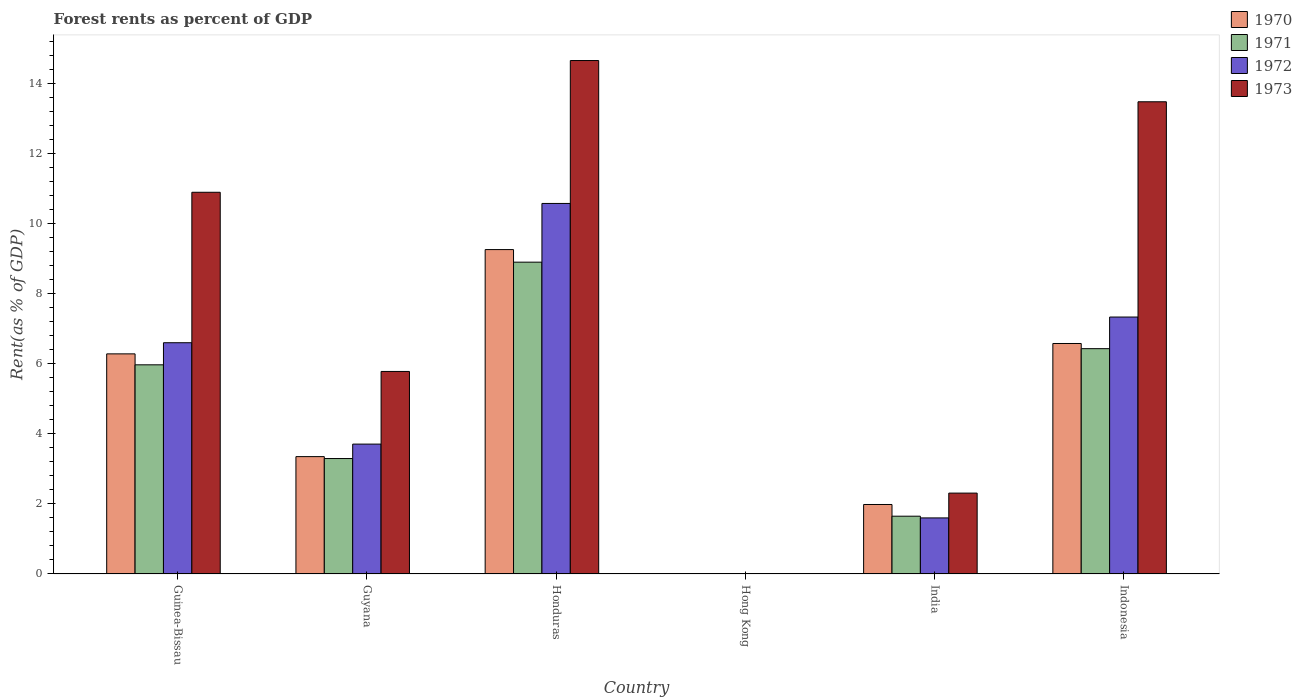How many different coloured bars are there?
Keep it short and to the point. 4. Are the number of bars per tick equal to the number of legend labels?
Provide a short and direct response. Yes. Are the number of bars on each tick of the X-axis equal?
Provide a succinct answer. Yes. How many bars are there on the 2nd tick from the left?
Keep it short and to the point. 4. How many bars are there on the 4th tick from the right?
Offer a terse response. 4. What is the label of the 2nd group of bars from the left?
Your response must be concise. Guyana. In how many cases, is the number of bars for a given country not equal to the number of legend labels?
Your answer should be compact. 0. What is the forest rent in 1970 in Guyana?
Provide a short and direct response. 3.35. Across all countries, what is the maximum forest rent in 1971?
Offer a terse response. 8.89. Across all countries, what is the minimum forest rent in 1973?
Provide a succinct answer. 0.01. In which country was the forest rent in 1970 maximum?
Ensure brevity in your answer.  Honduras. In which country was the forest rent in 1970 minimum?
Your answer should be compact. Hong Kong. What is the total forest rent in 1972 in the graph?
Ensure brevity in your answer.  29.8. What is the difference between the forest rent in 1971 in Guinea-Bissau and that in Honduras?
Give a very brief answer. -2.93. What is the difference between the forest rent in 1972 in Hong Kong and the forest rent in 1970 in Indonesia?
Offer a very short reply. -6.57. What is the average forest rent in 1971 per country?
Give a very brief answer. 4.37. What is the difference between the forest rent of/in 1972 and forest rent of/in 1973 in India?
Provide a succinct answer. -0.71. What is the ratio of the forest rent in 1972 in Guinea-Bissau to that in Guyana?
Keep it short and to the point. 1.78. What is the difference between the highest and the second highest forest rent in 1970?
Give a very brief answer. 2.68. What is the difference between the highest and the lowest forest rent in 1970?
Make the answer very short. 9.24. In how many countries, is the forest rent in 1972 greater than the average forest rent in 1972 taken over all countries?
Keep it short and to the point. 3. Is it the case that in every country, the sum of the forest rent in 1972 and forest rent in 1973 is greater than the sum of forest rent in 1970 and forest rent in 1971?
Offer a terse response. No. What does the 2nd bar from the right in Indonesia represents?
Provide a short and direct response. 1972. How many bars are there?
Your answer should be very brief. 24. Are all the bars in the graph horizontal?
Make the answer very short. No. How many countries are there in the graph?
Offer a terse response. 6. What is the difference between two consecutive major ticks on the Y-axis?
Provide a short and direct response. 2. Are the values on the major ticks of Y-axis written in scientific E-notation?
Provide a short and direct response. No. Does the graph contain any zero values?
Offer a very short reply. No. How are the legend labels stacked?
Provide a short and direct response. Vertical. What is the title of the graph?
Provide a short and direct response. Forest rents as percent of GDP. What is the label or title of the Y-axis?
Make the answer very short. Rent(as % of GDP). What is the Rent(as % of GDP) in 1970 in Guinea-Bissau?
Ensure brevity in your answer.  6.28. What is the Rent(as % of GDP) of 1971 in Guinea-Bissau?
Offer a terse response. 5.97. What is the Rent(as % of GDP) in 1972 in Guinea-Bissau?
Make the answer very short. 6.6. What is the Rent(as % of GDP) of 1973 in Guinea-Bissau?
Make the answer very short. 10.89. What is the Rent(as % of GDP) of 1970 in Guyana?
Give a very brief answer. 3.35. What is the Rent(as % of GDP) in 1971 in Guyana?
Ensure brevity in your answer.  3.29. What is the Rent(as % of GDP) in 1972 in Guyana?
Your response must be concise. 3.7. What is the Rent(as % of GDP) of 1973 in Guyana?
Keep it short and to the point. 5.78. What is the Rent(as % of GDP) of 1970 in Honduras?
Give a very brief answer. 9.25. What is the Rent(as % of GDP) of 1971 in Honduras?
Offer a very short reply. 8.89. What is the Rent(as % of GDP) in 1972 in Honduras?
Make the answer very short. 10.57. What is the Rent(as % of GDP) of 1973 in Honduras?
Provide a succinct answer. 14.64. What is the Rent(as % of GDP) in 1970 in Hong Kong?
Ensure brevity in your answer.  0.01. What is the Rent(as % of GDP) of 1971 in Hong Kong?
Provide a short and direct response. 0.01. What is the Rent(as % of GDP) of 1972 in Hong Kong?
Provide a succinct answer. 0.01. What is the Rent(as % of GDP) of 1973 in Hong Kong?
Offer a very short reply. 0.01. What is the Rent(as % of GDP) in 1970 in India?
Give a very brief answer. 1.98. What is the Rent(as % of GDP) in 1971 in India?
Ensure brevity in your answer.  1.65. What is the Rent(as % of GDP) in 1972 in India?
Offer a very short reply. 1.6. What is the Rent(as % of GDP) in 1973 in India?
Give a very brief answer. 2.31. What is the Rent(as % of GDP) of 1970 in Indonesia?
Your response must be concise. 6.57. What is the Rent(as % of GDP) in 1971 in Indonesia?
Your answer should be very brief. 6.43. What is the Rent(as % of GDP) in 1972 in Indonesia?
Offer a very short reply. 7.33. What is the Rent(as % of GDP) in 1973 in Indonesia?
Your answer should be very brief. 13.47. Across all countries, what is the maximum Rent(as % of GDP) in 1970?
Provide a succinct answer. 9.25. Across all countries, what is the maximum Rent(as % of GDP) in 1971?
Make the answer very short. 8.89. Across all countries, what is the maximum Rent(as % of GDP) in 1972?
Ensure brevity in your answer.  10.57. Across all countries, what is the maximum Rent(as % of GDP) of 1973?
Offer a very short reply. 14.64. Across all countries, what is the minimum Rent(as % of GDP) of 1970?
Offer a terse response. 0.01. Across all countries, what is the minimum Rent(as % of GDP) of 1971?
Your answer should be very brief. 0.01. Across all countries, what is the minimum Rent(as % of GDP) of 1972?
Provide a short and direct response. 0.01. Across all countries, what is the minimum Rent(as % of GDP) of 1973?
Your answer should be compact. 0.01. What is the total Rent(as % of GDP) in 1970 in the graph?
Your response must be concise. 27.44. What is the total Rent(as % of GDP) in 1971 in the graph?
Offer a terse response. 26.23. What is the total Rent(as % of GDP) in 1972 in the graph?
Your response must be concise. 29.8. What is the total Rent(as % of GDP) of 1973 in the graph?
Offer a terse response. 47.09. What is the difference between the Rent(as % of GDP) of 1970 in Guinea-Bissau and that in Guyana?
Offer a terse response. 2.93. What is the difference between the Rent(as % of GDP) in 1971 in Guinea-Bissau and that in Guyana?
Your response must be concise. 2.67. What is the difference between the Rent(as % of GDP) in 1972 in Guinea-Bissau and that in Guyana?
Provide a succinct answer. 2.89. What is the difference between the Rent(as % of GDP) in 1973 in Guinea-Bissau and that in Guyana?
Offer a terse response. 5.11. What is the difference between the Rent(as % of GDP) of 1970 in Guinea-Bissau and that in Honduras?
Offer a very short reply. -2.97. What is the difference between the Rent(as % of GDP) in 1971 in Guinea-Bissau and that in Honduras?
Make the answer very short. -2.93. What is the difference between the Rent(as % of GDP) in 1972 in Guinea-Bissau and that in Honduras?
Ensure brevity in your answer.  -3.97. What is the difference between the Rent(as % of GDP) in 1973 in Guinea-Bissau and that in Honduras?
Provide a succinct answer. -3.76. What is the difference between the Rent(as % of GDP) in 1970 in Guinea-Bissau and that in Hong Kong?
Ensure brevity in your answer.  6.27. What is the difference between the Rent(as % of GDP) of 1971 in Guinea-Bissau and that in Hong Kong?
Your response must be concise. 5.96. What is the difference between the Rent(as % of GDP) in 1972 in Guinea-Bissau and that in Hong Kong?
Your answer should be compact. 6.59. What is the difference between the Rent(as % of GDP) of 1973 in Guinea-Bissau and that in Hong Kong?
Provide a short and direct response. 10.88. What is the difference between the Rent(as % of GDP) of 1970 in Guinea-Bissau and that in India?
Offer a very short reply. 4.3. What is the difference between the Rent(as % of GDP) of 1971 in Guinea-Bissau and that in India?
Offer a terse response. 4.32. What is the difference between the Rent(as % of GDP) of 1972 in Guinea-Bissau and that in India?
Your answer should be very brief. 5. What is the difference between the Rent(as % of GDP) in 1973 in Guinea-Bissau and that in India?
Provide a short and direct response. 8.58. What is the difference between the Rent(as % of GDP) of 1970 in Guinea-Bissau and that in Indonesia?
Keep it short and to the point. -0.3. What is the difference between the Rent(as % of GDP) of 1971 in Guinea-Bissau and that in Indonesia?
Provide a succinct answer. -0.46. What is the difference between the Rent(as % of GDP) in 1972 in Guinea-Bissau and that in Indonesia?
Provide a succinct answer. -0.73. What is the difference between the Rent(as % of GDP) in 1973 in Guinea-Bissau and that in Indonesia?
Your answer should be compact. -2.58. What is the difference between the Rent(as % of GDP) in 1970 in Guyana and that in Honduras?
Give a very brief answer. -5.9. What is the difference between the Rent(as % of GDP) in 1971 in Guyana and that in Honduras?
Your answer should be compact. -5.6. What is the difference between the Rent(as % of GDP) in 1972 in Guyana and that in Honduras?
Provide a short and direct response. -6.86. What is the difference between the Rent(as % of GDP) in 1973 in Guyana and that in Honduras?
Provide a succinct answer. -8.87. What is the difference between the Rent(as % of GDP) of 1970 in Guyana and that in Hong Kong?
Provide a succinct answer. 3.34. What is the difference between the Rent(as % of GDP) in 1971 in Guyana and that in Hong Kong?
Ensure brevity in your answer.  3.29. What is the difference between the Rent(as % of GDP) in 1972 in Guyana and that in Hong Kong?
Ensure brevity in your answer.  3.7. What is the difference between the Rent(as % of GDP) of 1973 in Guyana and that in Hong Kong?
Provide a succinct answer. 5.77. What is the difference between the Rent(as % of GDP) of 1970 in Guyana and that in India?
Your answer should be very brief. 1.37. What is the difference between the Rent(as % of GDP) of 1971 in Guyana and that in India?
Make the answer very short. 1.64. What is the difference between the Rent(as % of GDP) of 1972 in Guyana and that in India?
Provide a succinct answer. 2.11. What is the difference between the Rent(as % of GDP) of 1973 in Guyana and that in India?
Your answer should be compact. 3.47. What is the difference between the Rent(as % of GDP) in 1970 in Guyana and that in Indonesia?
Make the answer very short. -3.23. What is the difference between the Rent(as % of GDP) of 1971 in Guyana and that in Indonesia?
Offer a terse response. -3.13. What is the difference between the Rent(as % of GDP) of 1972 in Guyana and that in Indonesia?
Provide a succinct answer. -3.62. What is the difference between the Rent(as % of GDP) of 1973 in Guyana and that in Indonesia?
Give a very brief answer. -7.69. What is the difference between the Rent(as % of GDP) in 1970 in Honduras and that in Hong Kong?
Your response must be concise. 9.24. What is the difference between the Rent(as % of GDP) in 1971 in Honduras and that in Hong Kong?
Offer a very short reply. 8.89. What is the difference between the Rent(as % of GDP) in 1972 in Honduras and that in Hong Kong?
Make the answer very short. 10.56. What is the difference between the Rent(as % of GDP) of 1973 in Honduras and that in Hong Kong?
Keep it short and to the point. 14.63. What is the difference between the Rent(as % of GDP) of 1970 in Honduras and that in India?
Offer a very short reply. 7.27. What is the difference between the Rent(as % of GDP) of 1971 in Honduras and that in India?
Provide a short and direct response. 7.24. What is the difference between the Rent(as % of GDP) of 1972 in Honduras and that in India?
Offer a very short reply. 8.97. What is the difference between the Rent(as % of GDP) in 1973 in Honduras and that in India?
Offer a terse response. 12.34. What is the difference between the Rent(as % of GDP) in 1970 in Honduras and that in Indonesia?
Provide a succinct answer. 2.68. What is the difference between the Rent(as % of GDP) in 1971 in Honduras and that in Indonesia?
Make the answer very short. 2.47. What is the difference between the Rent(as % of GDP) of 1972 in Honduras and that in Indonesia?
Your response must be concise. 3.24. What is the difference between the Rent(as % of GDP) of 1973 in Honduras and that in Indonesia?
Your response must be concise. 1.18. What is the difference between the Rent(as % of GDP) of 1970 in Hong Kong and that in India?
Your response must be concise. -1.97. What is the difference between the Rent(as % of GDP) in 1971 in Hong Kong and that in India?
Make the answer very short. -1.64. What is the difference between the Rent(as % of GDP) of 1972 in Hong Kong and that in India?
Make the answer very short. -1.59. What is the difference between the Rent(as % of GDP) of 1973 in Hong Kong and that in India?
Provide a short and direct response. -2.3. What is the difference between the Rent(as % of GDP) of 1970 in Hong Kong and that in Indonesia?
Provide a short and direct response. -6.56. What is the difference between the Rent(as % of GDP) in 1971 in Hong Kong and that in Indonesia?
Your answer should be compact. -6.42. What is the difference between the Rent(as % of GDP) of 1972 in Hong Kong and that in Indonesia?
Provide a short and direct response. -7.32. What is the difference between the Rent(as % of GDP) in 1973 in Hong Kong and that in Indonesia?
Give a very brief answer. -13.46. What is the difference between the Rent(as % of GDP) of 1970 in India and that in Indonesia?
Make the answer very short. -4.59. What is the difference between the Rent(as % of GDP) in 1971 in India and that in Indonesia?
Your answer should be compact. -4.78. What is the difference between the Rent(as % of GDP) in 1972 in India and that in Indonesia?
Provide a succinct answer. -5.73. What is the difference between the Rent(as % of GDP) in 1973 in India and that in Indonesia?
Make the answer very short. -11.16. What is the difference between the Rent(as % of GDP) of 1970 in Guinea-Bissau and the Rent(as % of GDP) of 1971 in Guyana?
Give a very brief answer. 2.99. What is the difference between the Rent(as % of GDP) of 1970 in Guinea-Bissau and the Rent(as % of GDP) of 1972 in Guyana?
Offer a very short reply. 2.57. What is the difference between the Rent(as % of GDP) of 1970 in Guinea-Bissau and the Rent(as % of GDP) of 1973 in Guyana?
Your answer should be compact. 0.5. What is the difference between the Rent(as % of GDP) in 1971 in Guinea-Bissau and the Rent(as % of GDP) in 1972 in Guyana?
Offer a terse response. 2.26. What is the difference between the Rent(as % of GDP) in 1971 in Guinea-Bissau and the Rent(as % of GDP) in 1973 in Guyana?
Your response must be concise. 0.19. What is the difference between the Rent(as % of GDP) of 1972 in Guinea-Bissau and the Rent(as % of GDP) of 1973 in Guyana?
Ensure brevity in your answer.  0.82. What is the difference between the Rent(as % of GDP) in 1970 in Guinea-Bissau and the Rent(as % of GDP) in 1971 in Honduras?
Offer a terse response. -2.62. What is the difference between the Rent(as % of GDP) of 1970 in Guinea-Bissau and the Rent(as % of GDP) of 1972 in Honduras?
Your answer should be compact. -4.29. What is the difference between the Rent(as % of GDP) of 1970 in Guinea-Bissau and the Rent(as % of GDP) of 1973 in Honduras?
Make the answer very short. -8.37. What is the difference between the Rent(as % of GDP) in 1971 in Guinea-Bissau and the Rent(as % of GDP) in 1972 in Honduras?
Your response must be concise. -4.6. What is the difference between the Rent(as % of GDP) in 1971 in Guinea-Bissau and the Rent(as % of GDP) in 1973 in Honduras?
Ensure brevity in your answer.  -8.68. What is the difference between the Rent(as % of GDP) in 1972 in Guinea-Bissau and the Rent(as % of GDP) in 1973 in Honduras?
Give a very brief answer. -8.05. What is the difference between the Rent(as % of GDP) of 1970 in Guinea-Bissau and the Rent(as % of GDP) of 1971 in Hong Kong?
Offer a very short reply. 6.27. What is the difference between the Rent(as % of GDP) of 1970 in Guinea-Bissau and the Rent(as % of GDP) of 1972 in Hong Kong?
Your response must be concise. 6.27. What is the difference between the Rent(as % of GDP) in 1970 in Guinea-Bissau and the Rent(as % of GDP) in 1973 in Hong Kong?
Your response must be concise. 6.27. What is the difference between the Rent(as % of GDP) of 1971 in Guinea-Bissau and the Rent(as % of GDP) of 1972 in Hong Kong?
Provide a short and direct response. 5.96. What is the difference between the Rent(as % of GDP) of 1971 in Guinea-Bissau and the Rent(as % of GDP) of 1973 in Hong Kong?
Make the answer very short. 5.95. What is the difference between the Rent(as % of GDP) of 1972 in Guinea-Bissau and the Rent(as % of GDP) of 1973 in Hong Kong?
Your answer should be compact. 6.58. What is the difference between the Rent(as % of GDP) in 1970 in Guinea-Bissau and the Rent(as % of GDP) in 1971 in India?
Make the answer very short. 4.63. What is the difference between the Rent(as % of GDP) in 1970 in Guinea-Bissau and the Rent(as % of GDP) in 1972 in India?
Make the answer very short. 4.68. What is the difference between the Rent(as % of GDP) of 1970 in Guinea-Bissau and the Rent(as % of GDP) of 1973 in India?
Offer a very short reply. 3.97. What is the difference between the Rent(as % of GDP) of 1971 in Guinea-Bissau and the Rent(as % of GDP) of 1972 in India?
Your answer should be very brief. 4.37. What is the difference between the Rent(as % of GDP) in 1971 in Guinea-Bissau and the Rent(as % of GDP) in 1973 in India?
Ensure brevity in your answer.  3.66. What is the difference between the Rent(as % of GDP) of 1972 in Guinea-Bissau and the Rent(as % of GDP) of 1973 in India?
Ensure brevity in your answer.  4.29. What is the difference between the Rent(as % of GDP) in 1970 in Guinea-Bissau and the Rent(as % of GDP) in 1971 in Indonesia?
Offer a very short reply. -0.15. What is the difference between the Rent(as % of GDP) of 1970 in Guinea-Bissau and the Rent(as % of GDP) of 1972 in Indonesia?
Your response must be concise. -1.05. What is the difference between the Rent(as % of GDP) in 1970 in Guinea-Bissau and the Rent(as % of GDP) in 1973 in Indonesia?
Your answer should be very brief. -7.19. What is the difference between the Rent(as % of GDP) of 1971 in Guinea-Bissau and the Rent(as % of GDP) of 1972 in Indonesia?
Make the answer very short. -1.36. What is the difference between the Rent(as % of GDP) of 1971 in Guinea-Bissau and the Rent(as % of GDP) of 1973 in Indonesia?
Ensure brevity in your answer.  -7.5. What is the difference between the Rent(as % of GDP) of 1972 in Guinea-Bissau and the Rent(as % of GDP) of 1973 in Indonesia?
Your answer should be very brief. -6.87. What is the difference between the Rent(as % of GDP) of 1970 in Guyana and the Rent(as % of GDP) of 1971 in Honduras?
Your response must be concise. -5.55. What is the difference between the Rent(as % of GDP) of 1970 in Guyana and the Rent(as % of GDP) of 1972 in Honduras?
Your answer should be very brief. -7.22. What is the difference between the Rent(as % of GDP) in 1970 in Guyana and the Rent(as % of GDP) in 1973 in Honduras?
Provide a short and direct response. -11.3. What is the difference between the Rent(as % of GDP) of 1971 in Guyana and the Rent(as % of GDP) of 1972 in Honduras?
Give a very brief answer. -7.28. What is the difference between the Rent(as % of GDP) of 1971 in Guyana and the Rent(as % of GDP) of 1973 in Honduras?
Ensure brevity in your answer.  -11.35. What is the difference between the Rent(as % of GDP) of 1972 in Guyana and the Rent(as % of GDP) of 1973 in Honduras?
Keep it short and to the point. -10.94. What is the difference between the Rent(as % of GDP) of 1970 in Guyana and the Rent(as % of GDP) of 1971 in Hong Kong?
Offer a very short reply. 3.34. What is the difference between the Rent(as % of GDP) of 1970 in Guyana and the Rent(as % of GDP) of 1972 in Hong Kong?
Your answer should be very brief. 3.34. What is the difference between the Rent(as % of GDP) of 1970 in Guyana and the Rent(as % of GDP) of 1973 in Hong Kong?
Keep it short and to the point. 3.34. What is the difference between the Rent(as % of GDP) in 1971 in Guyana and the Rent(as % of GDP) in 1972 in Hong Kong?
Offer a terse response. 3.29. What is the difference between the Rent(as % of GDP) of 1971 in Guyana and the Rent(as % of GDP) of 1973 in Hong Kong?
Provide a succinct answer. 3.28. What is the difference between the Rent(as % of GDP) in 1972 in Guyana and the Rent(as % of GDP) in 1973 in Hong Kong?
Offer a terse response. 3.69. What is the difference between the Rent(as % of GDP) of 1970 in Guyana and the Rent(as % of GDP) of 1971 in India?
Offer a very short reply. 1.7. What is the difference between the Rent(as % of GDP) in 1970 in Guyana and the Rent(as % of GDP) in 1972 in India?
Ensure brevity in your answer.  1.75. What is the difference between the Rent(as % of GDP) in 1970 in Guyana and the Rent(as % of GDP) in 1973 in India?
Your answer should be very brief. 1.04. What is the difference between the Rent(as % of GDP) of 1971 in Guyana and the Rent(as % of GDP) of 1972 in India?
Provide a succinct answer. 1.69. What is the difference between the Rent(as % of GDP) in 1972 in Guyana and the Rent(as % of GDP) in 1973 in India?
Your answer should be compact. 1.4. What is the difference between the Rent(as % of GDP) in 1970 in Guyana and the Rent(as % of GDP) in 1971 in Indonesia?
Your answer should be compact. -3.08. What is the difference between the Rent(as % of GDP) of 1970 in Guyana and the Rent(as % of GDP) of 1972 in Indonesia?
Provide a short and direct response. -3.98. What is the difference between the Rent(as % of GDP) of 1970 in Guyana and the Rent(as % of GDP) of 1973 in Indonesia?
Your answer should be very brief. -10.12. What is the difference between the Rent(as % of GDP) of 1971 in Guyana and the Rent(as % of GDP) of 1972 in Indonesia?
Provide a short and direct response. -4.04. What is the difference between the Rent(as % of GDP) in 1971 in Guyana and the Rent(as % of GDP) in 1973 in Indonesia?
Give a very brief answer. -10.18. What is the difference between the Rent(as % of GDP) in 1972 in Guyana and the Rent(as % of GDP) in 1973 in Indonesia?
Your response must be concise. -9.76. What is the difference between the Rent(as % of GDP) of 1970 in Honduras and the Rent(as % of GDP) of 1971 in Hong Kong?
Provide a succinct answer. 9.25. What is the difference between the Rent(as % of GDP) of 1970 in Honduras and the Rent(as % of GDP) of 1972 in Hong Kong?
Make the answer very short. 9.25. What is the difference between the Rent(as % of GDP) of 1970 in Honduras and the Rent(as % of GDP) of 1973 in Hong Kong?
Your response must be concise. 9.24. What is the difference between the Rent(as % of GDP) of 1971 in Honduras and the Rent(as % of GDP) of 1972 in Hong Kong?
Keep it short and to the point. 8.89. What is the difference between the Rent(as % of GDP) in 1971 in Honduras and the Rent(as % of GDP) in 1973 in Hong Kong?
Provide a succinct answer. 8.88. What is the difference between the Rent(as % of GDP) in 1972 in Honduras and the Rent(as % of GDP) in 1973 in Hong Kong?
Offer a terse response. 10.56. What is the difference between the Rent(as % of GDP) of 1970 in Honduras and the Rent(as % of GDP) of 1971 in India?
Give a very brief answer. 7.6. What is the difference between the Rent(as % of GDP) in 1970 in Honduras and the Rent(as % of GDP) in 1972 in India?
Ensure brevity in your answer.  7.65. What is the difference between the Rent(as % of GDP) in 1970 in Honduras and the Rent(as % of GDP) in 1973 in India?
Give a very brief answer. 6.95. What is the difference between the Rent(as % of GDP) of 1971 in Honduras and the Rent(as % of GDP) of 1972 in India?
Keep it short and to the point. 7.29. What is the difference between the Rent(as % of GDP) in 1971 in Honduras and the Rent(as % of GDP) in 1973 in India?
Give a very brief answer. 6.59. What is the difference between the Rent(as % of GDP) of 1972 in Honduras and the Rent(as % of GDP) of 1973 in India?
Give a very brief answer. 8.26. What is the difference between the Rent(as % of GDP) of 1970 in Honduras and the Rent(as % of GDP) of 1971 in Indonesia?
Offer a terse response. 2.83. What is the difference between the Rent(as % of GDP) in 1970 in Honduras and the Rent(as % of GDP) in 1972 in Indonesia?
Provide a short and direct response. 1.92. What is the difference between the Rent(as % of GDP) of 1970 in Honduras and the Rent(as % of GDP) of 1973 in Indonesia?
Provide a succinct answer. -4.22. What is the difference between the Rent(as % of GDP) of 1971 in Honduras and the Rent(as % of GDP) of 1972 in Indonesia?
Offer a terse response. 1.57. What is the difference between the Rent(as % of GDP) in 1971 in Honduras and the Rent(as % of GDP) in 1973 in Indonesia?
Make the answer very short. -4.57. What is the difference between the Rent(as % of GDP) of 1972 in Honduras and the Rent(as % of GDP) of 1973 in Indonesia?
Your answer should be very brief. -2.9. What is the difference between the Rent(as % of GDP) in 1970 in Hong Kong and the Rent(as % of GDP) in 1971 in India?
Your answer should be compact. -1.64. What is the difference between the Rent(as % of GDP) of 1970 in Hong Kong and the Rent(as % of GDP) of 1972 in India?
Ensure brevity in your answer.  -1.59. What is the difference between the Rent(as % of GDP) of 1970 in Hong Kong and the Rent(as % of GDP) of 1973 in India?
Offer a terse response. -2.3. What is the difference between the Rent(as % of GDP) in 1971 in Hong Kong and the Rent(as % of GDP) in 1972 in India?
Your response must be concise. -1.59. What is the difference between the Rent(as % of GDP) of 1971 in Hong Kong and the Rent(as % of GDP) of 1973 in India?
Offer a very short reply. -2.3. What is the difference between the Rent(as % of GDP) of 1972 in Hong Kong and the Rent(as % of GDP) of 1973 in India?
Make the answer very short. -2.3. What is the difference between the Rent(as % of GDP) in 1970 in Hong Kong and the Rent(as % of GDP) in 1971 in Indonesia?
Provide a succinct answer. -6.42. What is the difference between the Rent(as % of GDP) of 1970 in Hong Kong and the Rent(as % of GDP) of 1972 in Indonesia?
Provide a short and direct response. -7.32. What is the difference between the Rent(as % of GDP) of 1970 in Hong Kong and the Rent(as % of GDP) of 1973 in Indonesia?
Offer a terse response. -13.46. What is the difference between the Rent(as % of GDP) of 1971 in Hong Kong and the Rent(as % of GDP) of 1972 in Indonesia?
Ensure brevity in your answer.  -7.32. What is the difference between the Rent(as % of GDP) of 1971 in Hong Kong and the Rent(as % of GDP) of 1973 in Indonesia?
Keep it short and to the point. -13.46. What is the difference between the Rent(as % of GDP) in 1972 in Hong Kong and the Rent(as % of GDP) in 1973 in Indonesia?
Make the answer very short. -13.46. What is the difference between the Rent(as % of GDP) in 1970 in India and the Rent(as % of GDP) in 1971 in Indonesia?
Your answer should be compact. -4.44. What is the difference between the Rent(as % of GDP) in 1970 in India and the Rent(as % of GDP) in 1972 in Indonesia?
Ensure brevity in your answer.  -5.35. What is the difference between the Rent(as % of GDP) in 1970 in India and the Rent(as % of GDP) in 1973 in Indonesia?
Offer a terse response. -11.49. What is the difference between the Rent(as % of GDP) in 1971 in India and the Rent(as % of GDP) in 1972 in Indonesia?
Keep it short and to the point. -5.68. What is the difference between the Rent(as % of GDP) in 1971 in India and the Rent(as % of GDP) in 1973 in Indonesia?
Offer a very short reply. -11.82. What is the difference between the Rent(as % of GDP) of 1972 in India and the Rent(as % of GDP) of 1973 in Indonesia?
Your answer should be compact. -11.87. What is the average Rent(as % of GDP) in 1970 per country?
Give a very brief answer. 4.57. What is the average Rent(as % of GDP) of 1971 per country?
Provide a succinct answer. 4.37. What is the average Rent(as % of GDP) of 1972 per country?
Give a very brief answer. 4.97. What is the average Rent(as % of GDP) of 1973 per country?
Offer a terse response. 7.85. What is the difference between the Rent(as % of GDP) in 1970 and Rent(as % of GDP) in 1971 in Guinea-Bissau?
Offer a very short reply. 0.31. What is the difference between the Rent(as % of GDP) in 1970 and Rent(as % of GDP) in 1972 in Guinea-Bissau?
Keep it short and to the point. -0.32. What is the difference between the Rent(as % of GDP) of 1970 and Rent(as % of GDP) of 1973 in Guinea-Bissau?
Give a very brief answer. -4.61. What is the difference between the Rent(as % of GDP) of 1971 and Rent(as % of GDP) of 1972 in Guinea-Bissau?
Provide a succinct answer. -0.63. What is the difference between the Rent(as % of GDP) of 1971 and Rent(as % of GDP) of 1973 in Guinea-Bissau?
Offer a very short reply. -4.92. What is the difference between the Rent(as % of GDP) of 1972 and Rent(as % of GDP) of 1973 in Guinea-Bissau?
Your answer should be very brief. -4.29. What is the difference between the Rent(as % of GDP) of 1970 and Rent(as % of GDP) of 1971 in Guyana?
Offer a terse response. 0.05. What is the difference between the Rent(as % of GDP) of 1970 and Rent(as % of GDP) of 1972 in Guyana?
Give a very brief answer. -0.36. What is the difference between the Rent(as % of GDP) of 1970 and Rent(as % of GDP) of 1973 in Guyana?
Your answer should be very brief. -2.43. What is the difference between the Rent(as % of GDP) in 1971 and Rent(as % of GDP) in 1972 in Guyana?
Offer a terse response. -0.41. What is the difference between the Rent(as % of GDP) of 1971 and Rent(as % of GDP) of 1973 in Guyana?
Provide a short and direct response. -2.48. What is the difference between the Rent(as % of GDP) of 1972 and Rent(as % of GDP) of 1973 in Guyana?
Make the answer very short. -2.07. What is the difference between the Rent(as % of GDP) of 1970 and Rent(as % of GDP) of 1971 in Honduras?
Keep it short and to the point. 0.36. What is the difference between the Rent(as % of GDP) of 1970 and Rent(as % of GDP) of 1972 in Honduras?
Your response must be concise. -1.32. What is the difference between the Rent(as % of GDP) in 1970 and Rent(as % of GDP) in 1973 in Honduras?
Provide a short and direct response. -5.39. What is the difference between the Rent(as % of GDP) in 1971 and Rent(as % of GDP) in 1972 in Honduras?
Provide a short and direct response. -1.67. What is the difference between the Rent(as % of GDP) of 1971 and Rent(as % of GDP) of 1973 in Honduras?
Keep it short and to the point. -5.75. What is the difference between the Rent(as % of GDP) of 1972 and Rent(as % of GDP) of 1973 in Honduras?
Ensure brevity in your answer.  -4.08. What is the difference between the Rent(as % of GDP) of 1970 and Rent(as % of GDP) of 1971 in Hong Kong?
Make the answer very short. 0. What is the difference between the Rent(as % of GDP) of 1970 and Rent(as % of GDP) of 1972 in Hong Kong?
Give a very brief answer. 0. What is the difference between the Rent(as % of GDP) in 1970 and Rent(as % of GDP) in 1973 in Hong Kong?
Provide a succinct answer. -0. What is the difference between the Rent(as % of GDP) of 1971 and Rent(as % of GDP) of 1973 in Hong Kong?
Provide a succinct answer. -0. What is the difference between the Rent(as % of GDP) in 1972 and Rent(as % of GDP) in 1973 in Hong Kong?
Offer a very short reply. -0. What is the difference between the Rent(as % of GDP) in 1970 and Rent(as % of GDP) in 1971 in India?
Provide a short and direct response. 0.33. What is the difference between the Rent(as % of GDP) in 1970 and Rent(as % of GDP) in 1972 in India?
Provide a short and direct response. 0.38. What is the difference between the Rent(as % of GDP) in 1970 and Rent(as % of GDP) in 1973 in India?
Keep it short and to the point. -0.32. What is the difference between the Rent(as % of GDP) in 1971 and Rent(as % of GDP) in 1972 in India?
Offer a terse response. 0.05. What is the difference between the Rent(as % of GDP) of 1971 and Rent(as % of GDP) of 1973 in India?
Your answer should be compact. -0.66. What is the difference between the Rent(as % of GDP) of 1972 and Rent(as % of GDP) of 1973 in India?
Your response must be concise. -0.71. What is the difference between the Rent(as % of GDP) in 1970 and Rent(as % of GDP) in 1971 in Indonesia?
Provide a short and direct response. 0.15. What is the difference between the Rent(as % of GDP) in 1970 and Rent(as % of GDP) in 1972 in Indonesia?
Offer a very short reply. -0.75. What is the difference between the Rent(as % of GDP) in 1970 and Rent(as % of GDP) in 1973 in Indonesia?
Provide a succinct answer. -6.89. What is the difference between the Rent(as % of GDP) in 1971 and Rent(as % of GDP) in 1972 in Indonesia?
Keep it short and to the point. -0.9. What is the difference between the Rent(as % of GDP) in 1971 and Rent(as % of GDP) in 1973 in Indonesia?
Offer a terse response. -7.04. What is the difference between the Rent(as % of GDP) in 1972 and Rent(as % of GDP) in 1973 in Indonesia?
Your answer should be very brief. -6.14. What is the ratio of the Rent(as % of GDP) of 1970 in Guinea-Bissau to that in Guyana?
Your answer should be very brief. 1.88. What is the ratio of the Rent(as % of GDP) of 1971 in Guinea-Bissau to that in Guyana?
Give a very brief answer. 1.81. What is the ratio of the Rent(as % of GDP) in 1972 in Guinea-Bissau to that in Guyana?
Make the answer very short. 1.78. What is the ratio of the Rent(as % of GDP) of 1973 in Guinea-Bissau to that in Guyana?
Provide a succinct answer. 1.88. What is the ratio of the Rent(as % of GDP) of 1970 in Guinea-Bissau to that in Honduras?
Provide a succinct answer. 0.68. What is the ratio of the Rent(as % of GDP) of 1971 in Guinea-Bissau to that in Honduras?
Your answer should be very brief. 0.67. What is the ratio of the Rent(as % of GDP) in 1972 in Guinea-Bissau to that in Honduras?
Provide a succinct answer. 0.62. What is the ratio of the Rent(as % of GDP) of 1973 in Guinea-Bissau to that in Honduras?
Keep it short and to the point. 0.74. What is the ratio of the Rent(as % of GDP) in 1970 in Guinea-Bissau to that in Hong Kong?
Your response must be concise. 639.74. What is the ratio of the Rent(as % of GDP) of 1971 in Guinea-Bissau to that in Hong Kong?
Your answer should be compact. 907.52. What is the ratio of the Rent(as % of GDP) of 1972 in Guinea-Bissau to that in Hong Kong?
Provide a short and direct response. 1022.94. What is the ratio of the Rent(as % of GDP) of 1973 in Guinea-Bissau to that in Hong Kong?
Give a very brief answer. 1008.57. What is the ratio of the Rent(as % of GDP) in 1970 in Guinea-Bissau to that in India?
Ensure brevity in your answer.  3.17. What is the ratio of the Rent(as % of GDP) of 1971 in Guinea-Bissau to that in India?
Offer a very short reply. 3.62. What is the ratio of the Rent(as % of GDP) in 1972 in Guinea-Bissau to that in India?
Ensure brevity in your answer.  4.12. What is the ratio of the Rent(as % of GDP) of 1973 in Guinea-Bissau to that in India?
Offer a very short reply. 4.72. What is the ratio of the Rent(as % of GDP) in 1970 in Guinea-Bissau to that in Indonesia?
Keep it short and to the point. 0.95. What is the ratio of the Rent(as % of GDP) in 1971 in Guinea-Bissau to that in Indonesia?
Offer a very short reply. 0.93. What is the ratio of the Rent(as % of GDP) in 1973 in Guinea-Bissau to that in Indonesia?
Make the answer very short. 0.81. What is the ratio of the Rent(as % of GDP) of 1970 in Guyana to that in Honduras?
Make the answer very short. 0.36. What is the ratio of the Rent(as % of GDP) of 1971 in Guyana to that in Honduras?
Your answer should be compact. 0.37. What is the ratio of the Rent(as % of GDP) in 1972 in Guyana to that in Honduras?
Your answer should be very brief. 0.35. What is the ratio of the Rent(as % of GDP) of 1973 in Guyana to that in Honduras?
Your answer should be compact. 0.39. What is the ratio of the Rent(as % of GDP) of 1970 in Guyana to that in Hong Kong?
Make the answer very short. 341.1. What is the ratio of the Rent(as % of GDP) of 1971 in Guyana to that in Hong Kong?
Keep it short and to the point. 500.92. What is the ratio of the Rent(as % of GDP) of 1972 in Guyana to that in Hong Kong?
Your answer should be compact. 574.53. What is the ratio of the Rent(as % of GDP) of 1973 in Guyana to that in Hong Kong?
Provide a succinct answer. 535.14. What is the ratio of the Rent(as % of GDP) of 1970 in Guyana to that in India?
Offer a very short reply. 1.69. What is the ratio of the Rent(as % of GDP) of 1971 in Guyana to that in India?
Offer a very short reply. 2. What is the ratio of the Rent(as % of GDP) of 1972 in Guyana to that in India?
Provide a short and direct response. 2.32. What is the ratio of the Rent(as % of GDP) of 1973 in Guyana to that in India?
Offer a terse response. 2.5. What is the ratio of the Rent(as % of GDP) in 1970 in Guyana to that in Indonesia?
Your answer should be very brief. 0.51. What is the ratio of the Rent(as % of GDP) of 1971 in Guyana to that in Indonesia?
Offer a terse response. 0.51. What is the ratio of the Rent(as % of GDP) of 1972 in Guyana to that in Indonesia?
Offer a terse response. 0.51. What is the ratio of the Rent(as % of GDP) in 1973 in Guyana to that in Indonesia?
Provide a short and direct response. 0.43. What is the ratio of the Rent(as % of GDP) of 1970 in Honduras to that in Hong Kong?
Your answer should be very brief. 942.83. What is the ratio of the Rent(as % of GDP) in 1971 in Honduras to that in Hong Kong?
Keep it short and to the point. 1352.94. What is the ratio of the Rent(as % of GDP) in 1972 in Honduras to that in Hong Kong?
Provide a succinct answer. 1639.07. What is the ratio of the Rent(as % of GDP) of 1973 in Honduras to that in Hong Kong?
Provide a short and direct response. 1356.64. What is the ratio of the Rent(as % of GDP) of 1970 in Honduras to that in India?
Offer a very short reply. 4.67. What is the ratio of the Rent(as % of GDP) of 1971 in Honduras to that in India?
Your answer should be very brief. 5.4. What is the ratio of the Rent(as % of GDP) of 1972 in Honduras to that in India?
Keep it short and to the point. 6.61. What is the ratio of the Rent(as % of GDP) in 1973 in Honduras to that in India?
Give a very brief answer. 6.35. What is the ratio of the Rent(as % of GDP) of 1970 in Honduras to that in Indonesia?
Provide a short and direct response. 1.41. What is the ratio of the Rent(as % of GDP) of 1971 in Honduras to that in Indonesia?
Make the answer very short. 1.38. What is the ratio of the Rent(as % of GDP) of 1972 in Honduras to that in Indonesia?
Make the answer very short. 1.44. What is the ratio of the Rent(as % of GDP) of 1973 in Honduras to that in Indonesia?
Give a very brief answer. 1.09. What is the ratio of the Rent(as % of GDP) of 1970 in Hong Kong to that in India?
Provide a short and direct response. 0.01. What is the ratio of the Rent(as % of GDP) of 1971 in Hong Kong to that in India?
Offer a terse response. 0. What is the ratio of the Rent(as % of GDP) of 1972 in Hong Kong to that in India?
Offer a very short reply. 0. What is the ratio of the Rent(as % of GDP) of 1973 in Hong Kong to that in India?
Your answer should be compact. 0. What is the ratio of the Rent(as % of GDP) of 1970 in Hong Kong to that in Indonesia?
Make the answer very short. 0. What is the ratio of the Rent(as % of GDP) of 1971 in Hong Kong to that in Indonesia?
Give a very brief answer. 0. What is the ratio of the Rent(as % of GDP) in 1972 in Hong Kong to that in Indonesia?
Your answer should be very brief. 0. What is the ratio of the Rent(as % of GDP) of 1973 in Hong Kong to that in Indonesia?
Your answer should be very brief. 0. What is the ratio of the Rent(as % of GDP) of 1970 in India to that in Indonesia?
Offer a very short reply. 0.3. What is the ratio of the Rent(as % of GDP) of 1971 in India to that in Indonesia?
Provide a succinct answer. 0.26. What is the ratio of the Rent(as % of GDP) in 1972 in India to that in Indonesia?
Make the answer very short. 0.22. What is the ratio of the Rent(as % of GDP) of 1973 in India to that in Indonesia?
Your answer should be compact. 0.17. What is the difference between the highest and the second highest Rent(as % of GDP) in 1970?
Offer a terse response. 2.68. What is the difference between the highest and the second highest Rent(as % of GDP) in 1971?
Give a very brief answer. 2.47. What is the difference between the highest and the second highest Rent(as % of GDP) of 1972?
Offer a terse response. 3.24. What is the difference between the highest and the second highest Rent(as % of GDP) of 1973?
Your answer should be compact. 1.18. What is the difference between the highest and the lowest Rent(as % of GDP) in 1970?
Your response must be concise. 9.24. What is the difference between the highest and the lowest Rent(as % of GDP) of 1971?
Provide a succinct answer. 8.89. What is the difference between the highest and the lowest Rent(as % of GDP) of 1972?
Ensure brevity in your answer.  10.56. What is the difference between the highest and the lowest Rent(as % of GDP) in 1973?
Give a very brief answer. 14.63. 